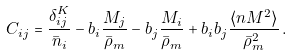Convert formula to latex. <formula><loc_0><loc_0><loc_500><loc_500>C _ { i j } = \frac { \delta ^ { K } _ { i j } } { \bar { n } _ { i } } - b _ { i } \frac { M _ { j } } { \bar { \rho } _ { m } } - b _ { j } \frac { M _ { i } } { \bar { \rho } _ { m } } + b _ { i } b _ { j } \frac { \langle n M ^ { 2 } \rangle } { \bar { \rho } _ { m } ^ { 2 } } \, .</formula> 